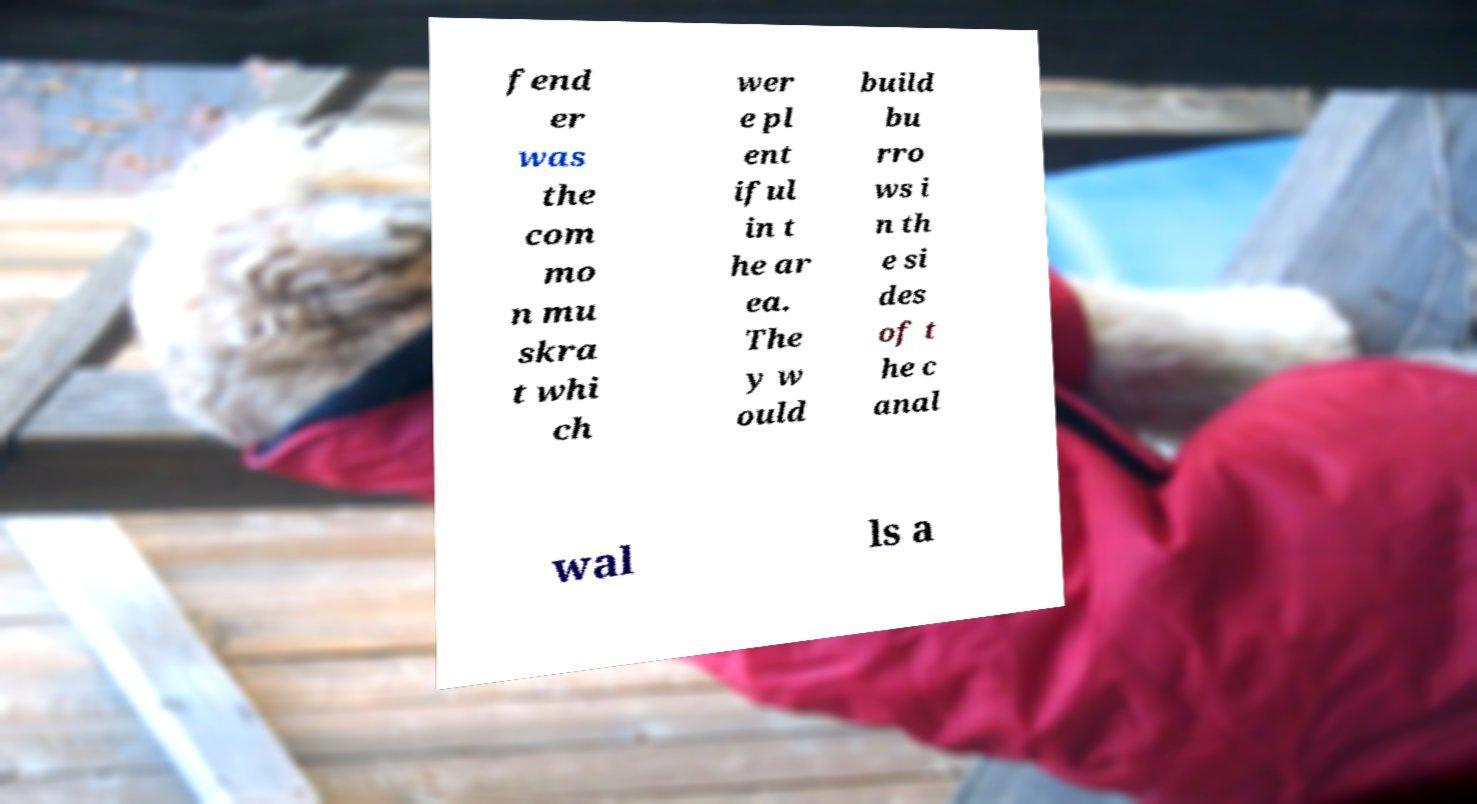There's text embedded in this image that I need extracted. Can you transcribe it verbatim? fend er was the com mo n mu skra t whi ch wer e pl ent iful in t he ar ea. The y w ould build bu rro ws i n th e si des of t he c anal wal ls a 